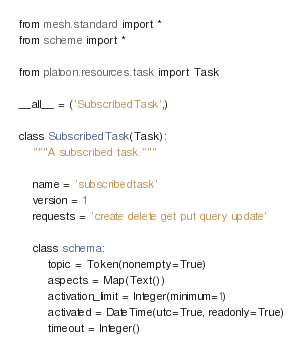<code> <loc_0><loc_0><loc_500><loc_500><_Python_>from mesh.standard import *
from scheme import *

from platoon.resources.task import Task

__all__ = ('SubscribedTask',)

class SubscribedTask(Task):
    """A subscribed task."""

    name = 'subscribedtask'
    version = 1
    requests = 'create delete get put query update'

    class schema:
        topic = Token(nonempty=True)
        aspects = Map(Text())
        activation_limit = Integer(minimum=1)
        activated = DateTime(utc=True, readonly=True)
        timeout = Integer()
</code> 